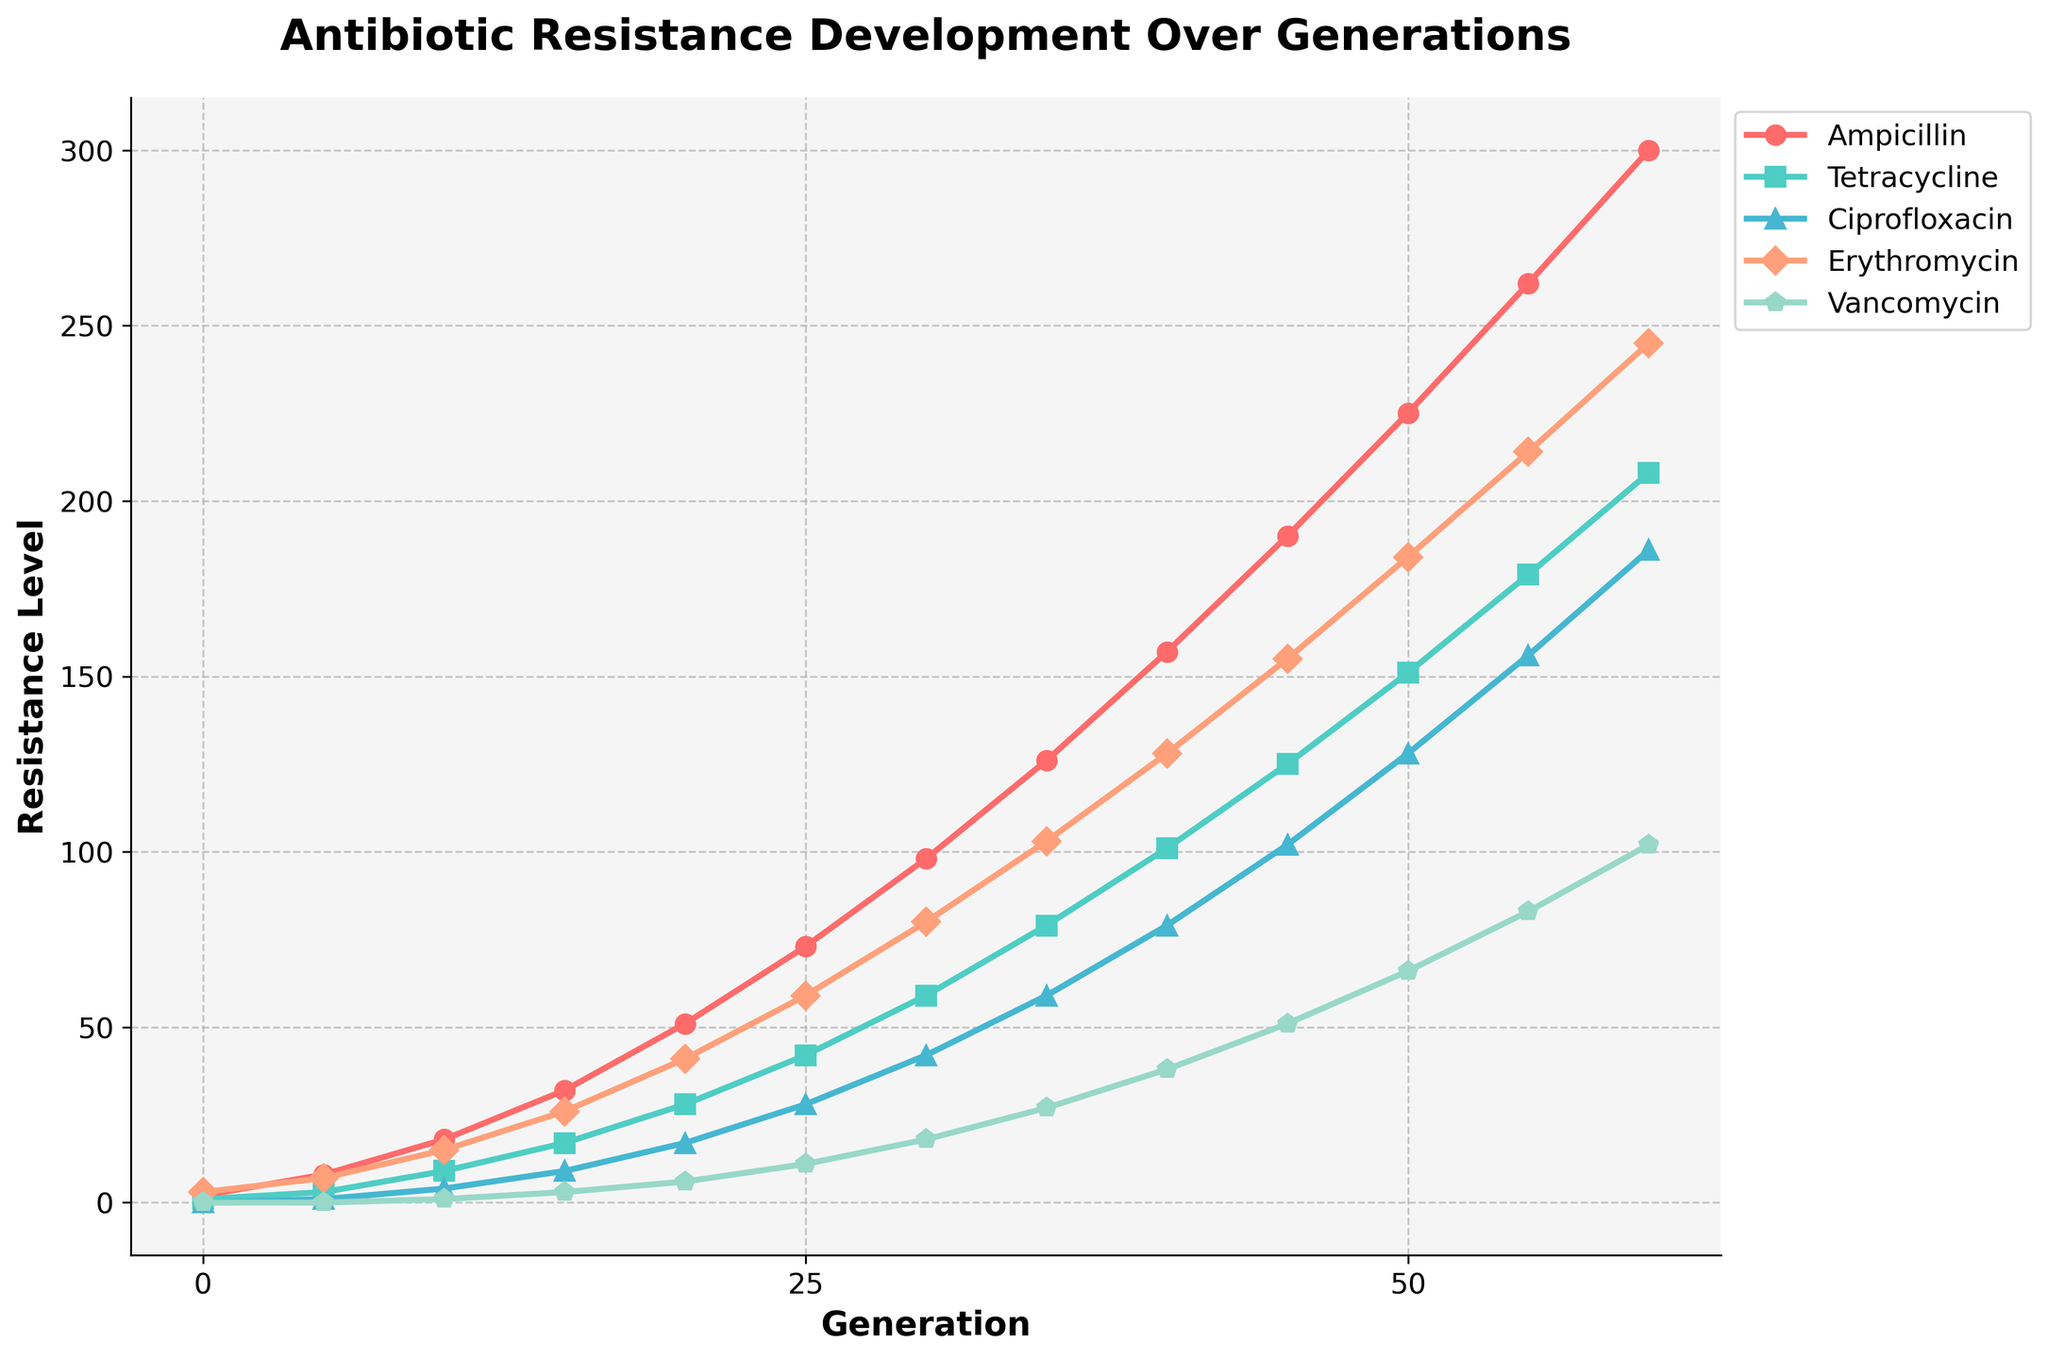Which antibiotic shows the highest resistance level at Generation 30? Look at the resistance levels for each antibiotic at Generation 30. The antibiotic with the highest value is Erythromycin at 80.
Answer: Erythromycin Between which generations does Ciprofloxacin show the greatest increase in resistance level? Compare the differences in resistance levels between consecutive generations for Ciprofloxacin. The largest increase occurs from Generation 50 (128) to Generation 55 (156), an increment of 28.
Answer: Generation 50 to 55 What is the average resistance level of Tetracycline over all generations? Sum the resistance levels of Tetracycline from Generation 0 to 60 then divide by the number of generations (13). The total sum is 1003, so the average is 1003 / 13 ≈ 77.15.
Answer: 77.15 Which antibiotic displayed the least increase in resistance level over the entire period? Calculate the increase from Generation 0 to Generation 60 for each antibiotic. Vancomycin increased by 102, which is the smallest increment.
Answer: Vancomycin At Generation 40, which two antibiotics have the closest resistance levels? Find the resistance levels at Generation 40 and check the differences. Ampicillin (157) and Erythromycin (128) have the closest resistance levels with a difference of 29.
Answer: Ampicillin and Erythromycin How does the resistance trend of Vancomycin differ in shape compared to the other antibiotics? Observe the shape of the Vancomycin line which consistently shows lower values and less steep increments compared to the others. This indicates a slower development of resistance.
Answer: Slower development, less steep Over how many generations did Tetracycline's resistance increase most rapidly? Look at the steepest segment of the Tetracycline line. The most rapid increase is from Generation 0 to 10, where it goes from 1 to 9.
Answer: Generation 0 to 10 Which antibiotic has the highest initial resistance and how does its growth compare to the others by Generation 60? Erythromycin starts at 3, the highest initial value. By Generation 60, its level (245) is second to Ampicillin (300), indicating rapid growth but slightly slower than Ampicillin.
Answer: Erythromycin, Rapid but not the highest 